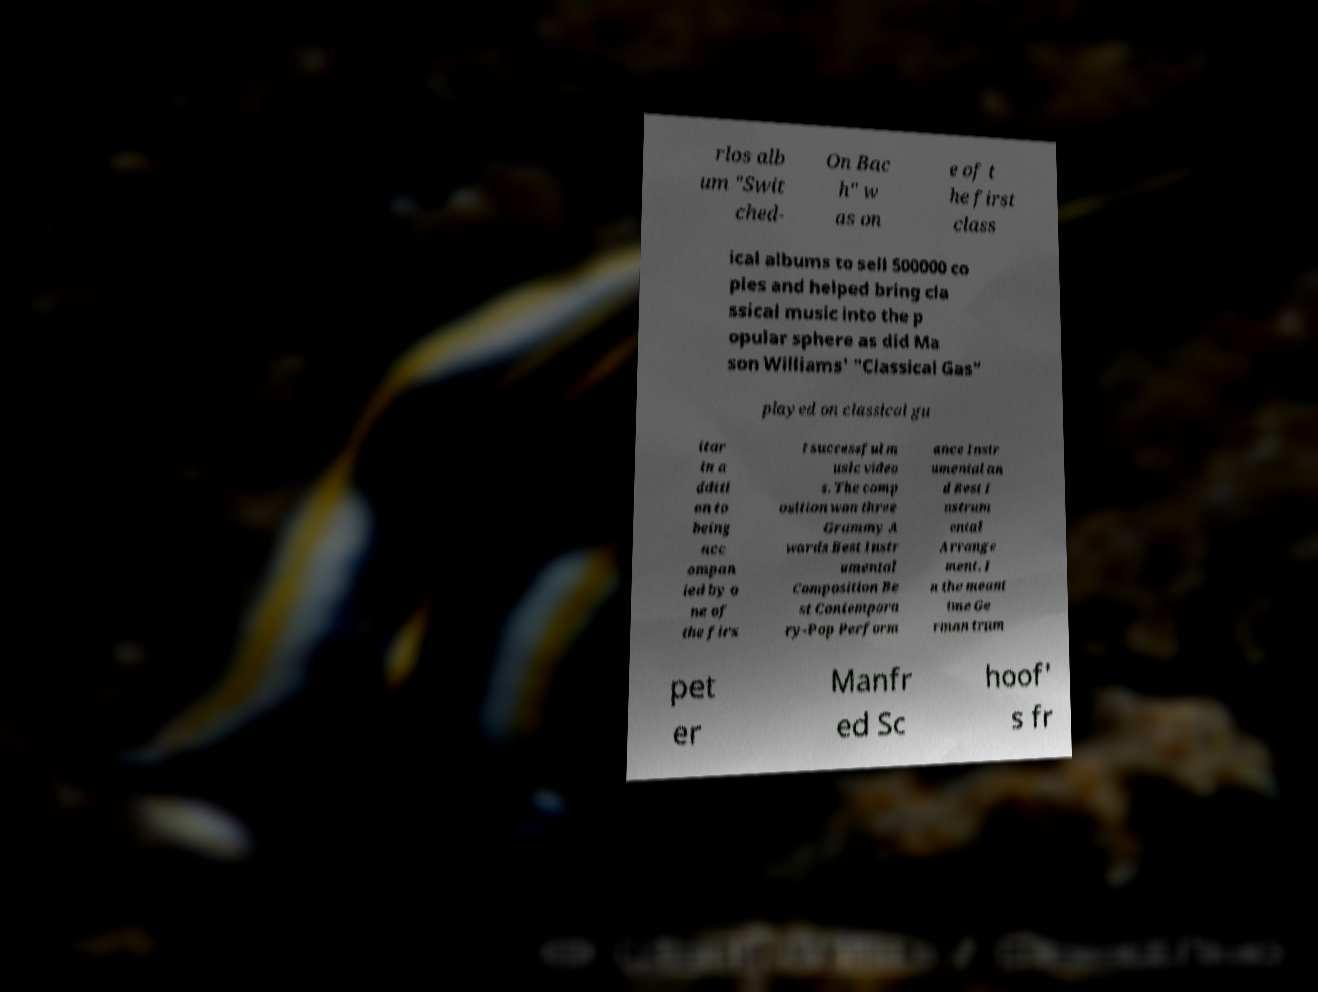For documentation purposes, I need the text within this image transcribed. Could you provide that? rlos alb um "Swit ched- On Bac h" w as on e of t he first class ical albums to sell 500000 co pies and helped bring cla ssical music into the p opular sphere as did Ma son Williams' "Classical Gas" played on classical gu itar in a dditi on to being acc ompan ied by o ne of the firs t successful m usic video s. The comp osition won three Grammy A wards Best Instr umental Composition Be st Contempora ry-Pop Perform ance Instr umental an d Best I nstrum ental Arrange ment. I n the meant ime Ge rman trum pet er Manfr ed Sc hoof' s fr 